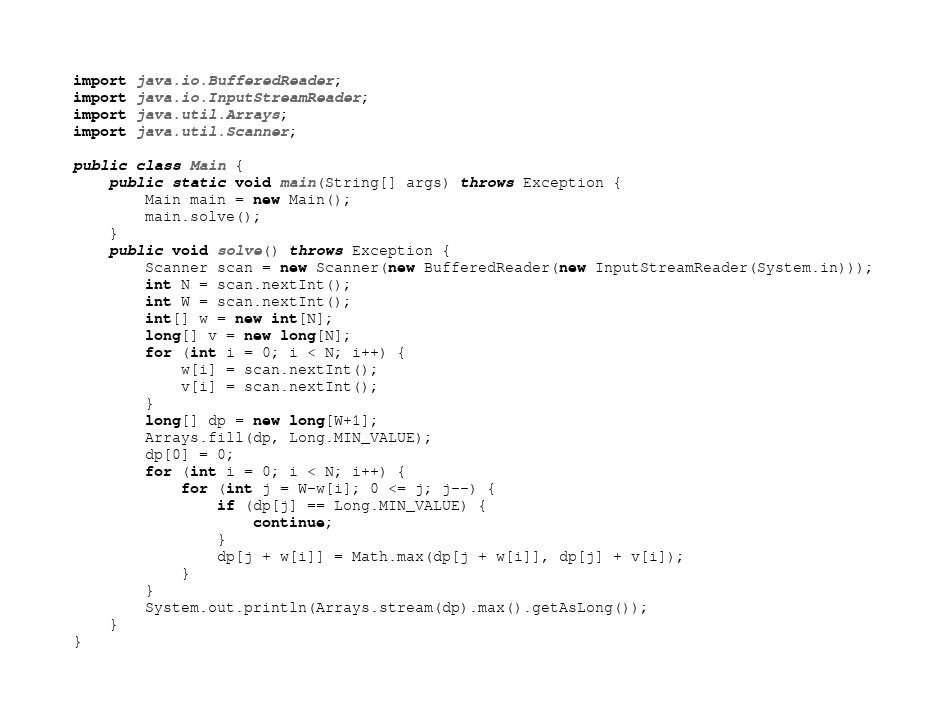Convert code to text. <code><loc_0><loc_0><loc_500><loc_500><_Java_>import java.io.BufferedReader;
import java.io.InputStreamReader;
import java.util.Arrays;
import java.util.Scanner;

public class Main {
    public static void main(String[] args) throws Exception {
        Main main = new Main();
        main.solve();
    }
    public void solve() throws Exception {
        Scanner scan = new Scanner(new BufferedReader(new InputStreamReader(System.in)));
        int N = scan.nextInt();
        int W = scan.nextInt();
        int[] w = new int[N];
        long[] v = new long[N];
        for (int i = 0; i < N; i++) {
            w[i] = scan.nextInt();
            v[i] = scan.nextInt();
        }
        long[] dp = new long[W+1];
        Arrays.fill(dp, Long.MIN_VALUE);
        dp[0] = 0;
        for (int i = 0; i < N; i++) {
            for (int j = W-w[i]; 0 <= j; j--) {
                if (dp[j] == Long.MIN_VALUE) {
                    continue;
                }
                dp[j + w[i]] = Math.max(dp[j + w[i]], dp[j] + v[i]);
            }
        }
        System.out.println(Arrays.stream(dp).max().getAsLong());
    }
}
</code> 